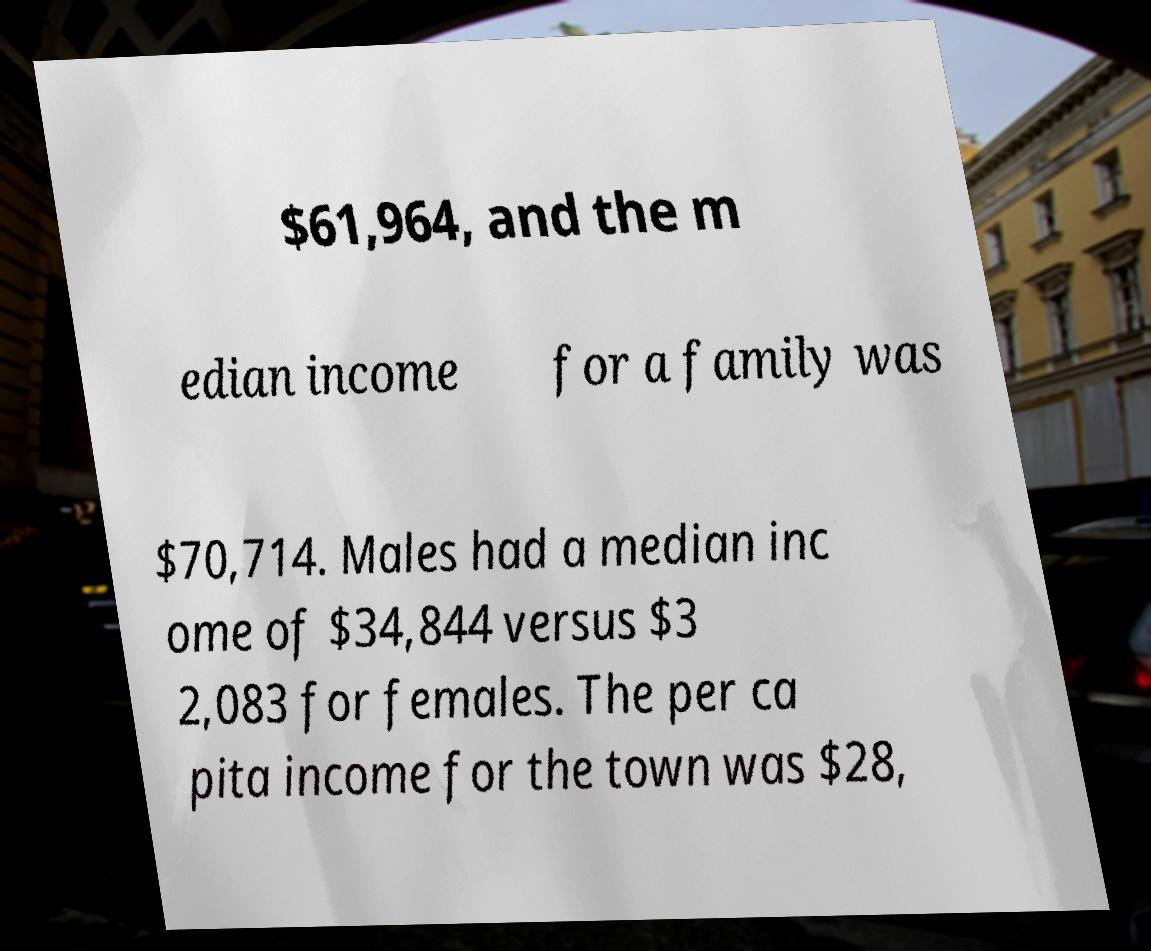Please identify and transcribe the text found in this image. $61,964, and the m edian income for a family was $70,714. Males had a median inc ome of $34,844 versus $3 2,083 for females. The per ca pita income for the town was $28, 